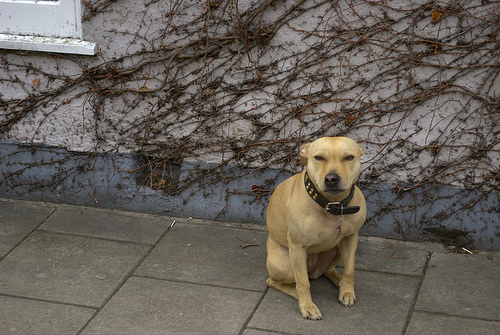What might the dog be feeling or thinking in this moment? While we can't know for sure, the dog's body language, with its relaxed posture and attentive gaze, might suggest it is calm and perhaps waiting patiently for its owner. 